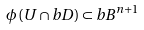Convert formula to latex. <formula><loc_0><loc_0><loc_500><loc_500>\phi \left ( U \cap b D \right ) \subset b B ^ { n + 1 }</formula> 